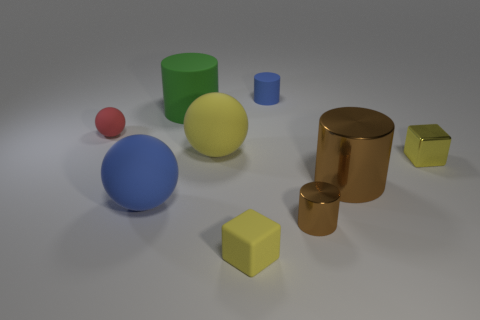How many balls are either large yellow matte objects or tiny yellow matte objects?
Provide a succinct answer. 1. What is the color of the small block on the left side of the small cylinder behind the tiny red rubber sphere?
Provide a succinct answer. Yellow. There is a small sphere; is it the same color as the tiny block behind the small matte block?
Keep it short and to the point. No. The cube that is made of the same material as the tiny brown object is what size?
Keep it short and to the point. Small. There is another cylinder that is the same color as the tiny shiny cylinder; what size is it?
Offer a very short reply. Large. Is the color of the big shiny object the same as the tiny rubber cube?
Your answer should be compact. No. Is there a yellow block behind the green cylinder in front of the tiny cylinder that is behind the metallic block?
Your answer should be very brief. No. What number of matte spheres have the same size as the yellow rubber block?
Your answer should be very brief. 1. There is a yellow cube to the left of the big brown metallic cylinder; is its size the same as the matte ball that is in front of the large brown metal object?
Your response must be concise. No. What shape is the rubber thing that is both right of the big yellow ball and in front of the large brown metallic cylinder?
Provide a succinct answer. Cube. 